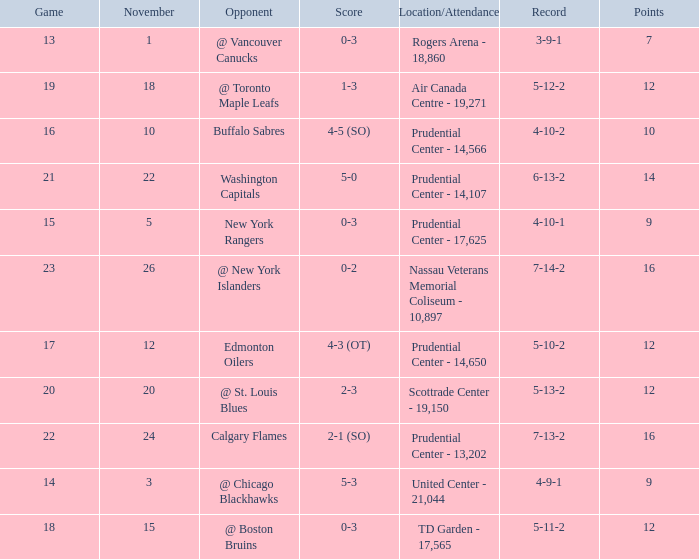Parse the table in full. {'header': ['Game', 'November', 'Opponent', 'Score', 'Location/Attendance', 'Record', 'Points'], 'rows': [['13', '1', '@ Vancouver Canucks', '0-3', 'Rogers Arena - 18,860', '3-9-1', '7'], ['19', '18', '@ Toronto Maple Leafs', '1-3', 'Air Canada Centre - 19,271', '5-12-2', '12'], ['16', '10', 'Buffalo Sabres', '4-5 (SO)', 'Prudential Center - 14,566', '4-10-2', '10'], ['21', '22', 'Washington Capitals', '5-0', 'Prudential Center - 14,107', '6-13-2', '14'], ['15', '5', 'New York Rangers', '0-3', 'Prudential Center - 17,625', '4-10-1', '9'], ['23', '26', '@ New York Islanders', '0-2', 'Nassau Veterans Memorial Coliseum - 10,897', '7-14-2', '16'], ['17', '12', 'Edmonton Oilers', '4-3 (OT)', 'Prudential Center - 14,650', '5-10-2', '12'], ['20', '20', '@ St. Louis Blues', '2-3', 'Scottrade Center - 19,150', '5-13-2', '12'], ['22', '24', 'Calgary Flames', '2-1 (SO)', 'Prudential Center - 13,202', '7-13-2', '16'], ['14', '3', '@ Chicago Blackhawks', '5-3', 'United Center - 21,044', '4-9-1', '9'], ['18', '15', '@ Boston Bruins', '0-3', 'TD Garden - 17,565', '5-11-2', '12']]} What is the maximum number of points? 16.0. 